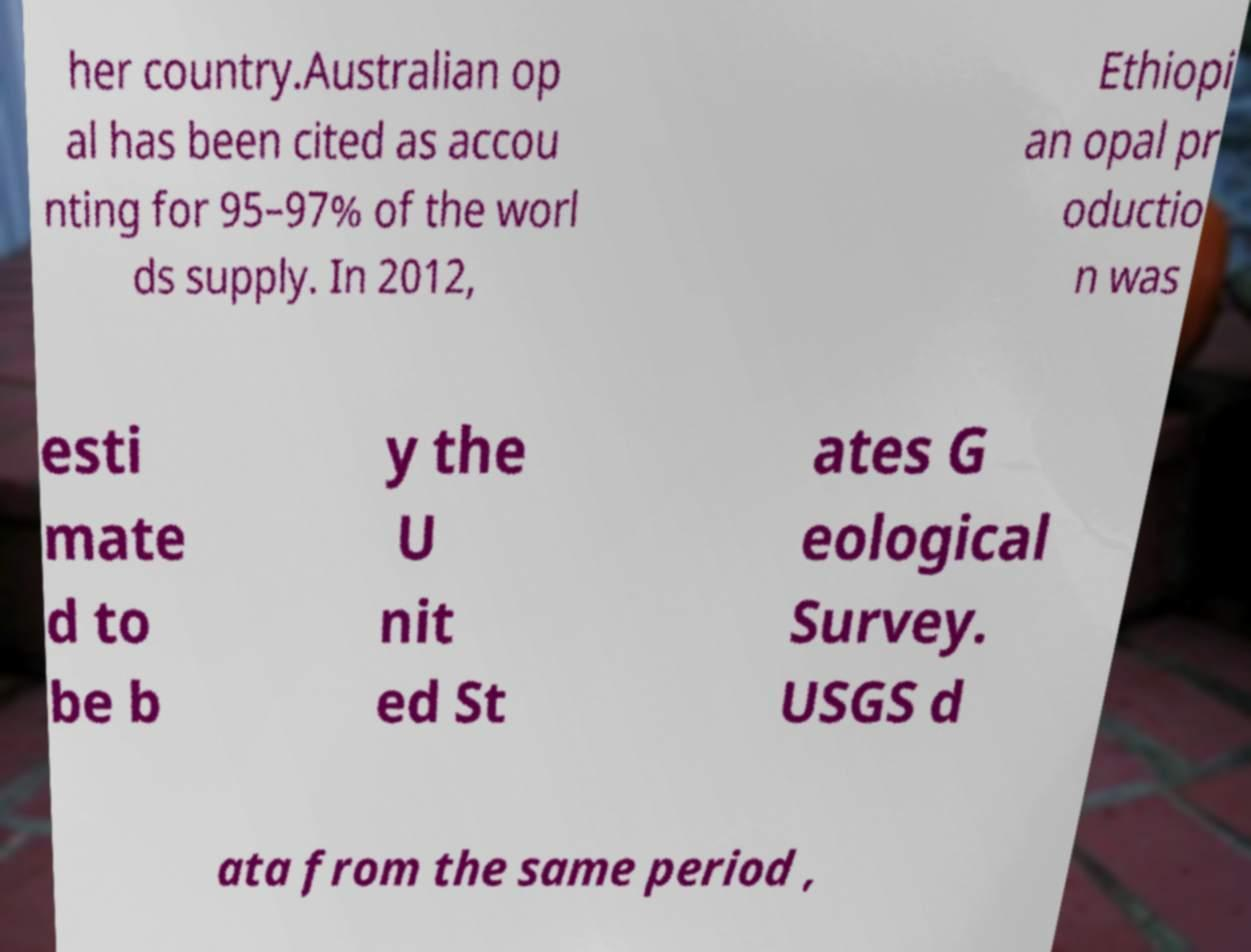Could you extract and type out the text from this image? her country.Australian op al has been cited as accou nting for 95–97% of the worl ds supply. In 2012, Ethiopi an opal pr oductio n was esti mate d to be b y the U nit ed St ates G eological Survey. USGS d ata from the same period , 